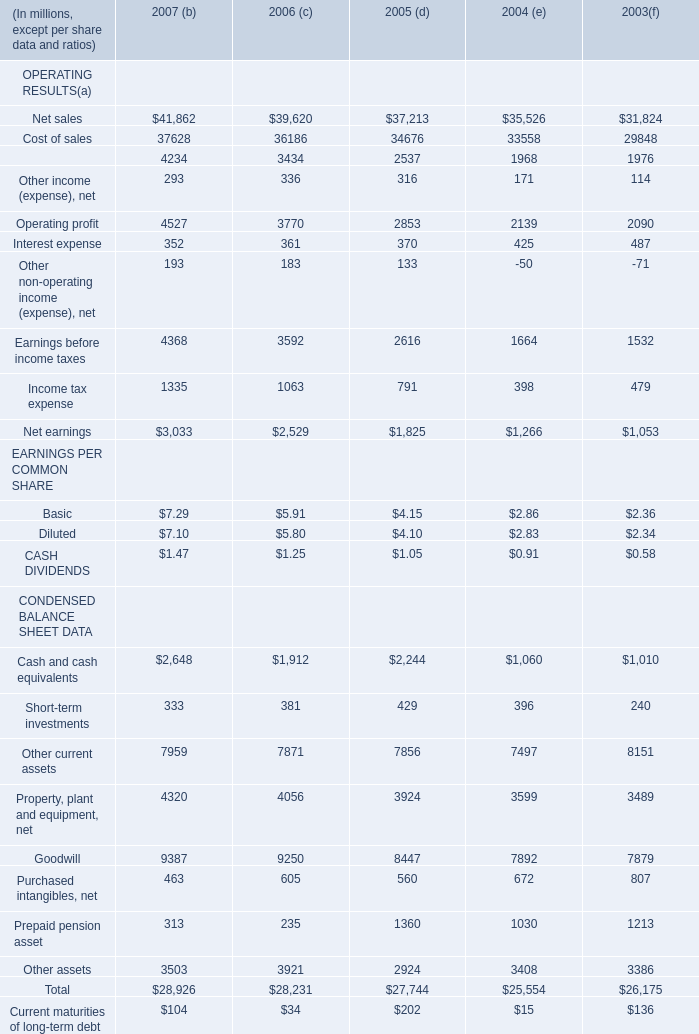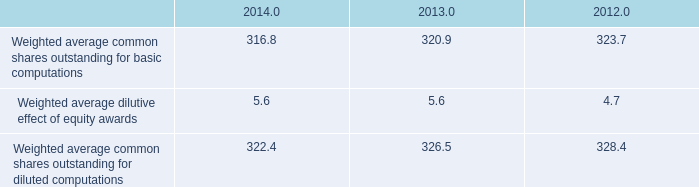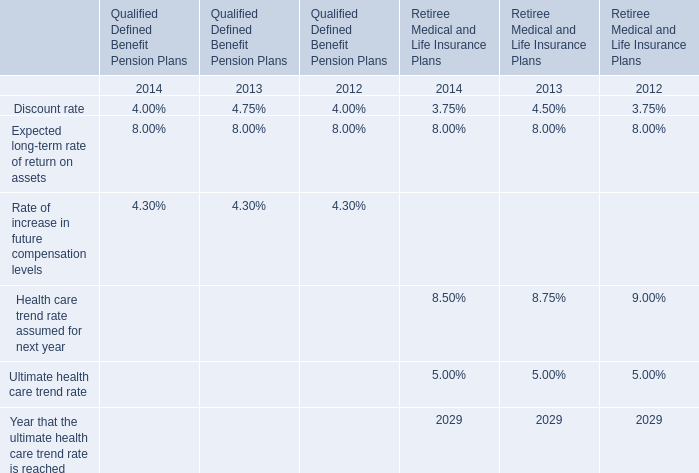What was the total amount of CONDENSED BALANCE SHEET DATA excluding those CONDENSED BALANCE SHEET DATA greater than 7000 in 2006? (in million) 
Computations: ((333 + 463) + 313)
Answer: 1109.0. 